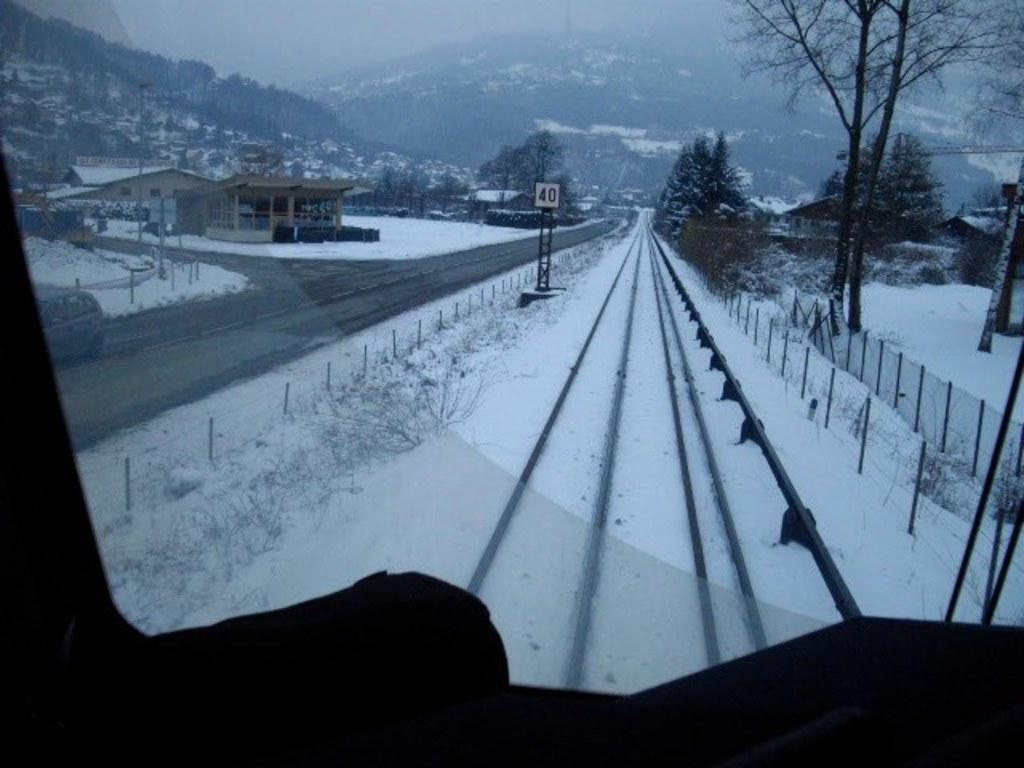What type of transportation infrastructure is present in the image? There is a railway track in the image. What weather condition is depicted in the image? There is snow in the image. What type of barrier can be seen in the image? There is a fence in the image. What type of structures are visible in the image? There are buildings in the image. What type of natural vegetation is present in the image? There are trees in the image. What type of vertical structure is present in the image? There is a pole in the image. What type of natural landform is present in the image? There are hills in the image. What type of harmony can be heard in the image? There is no audible harmony present in the image, as it is a visual representation. What type of leather material is visible in the image? There is no leather material present in the image. 